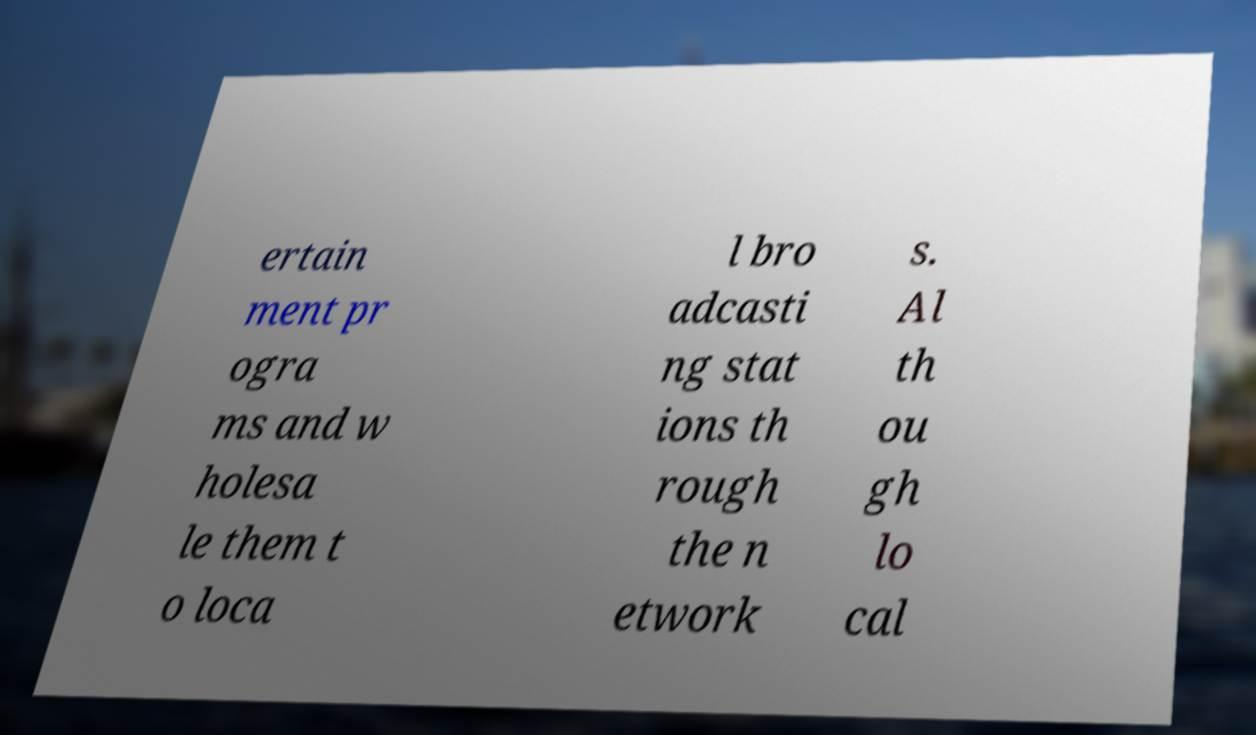For documentation purposes, I need the text within this image transcribed. Could you provide that? ertain ment pr ogra ms and w holesa le them t o loca l bro adcasti ng stat ions th rough the n etwork s. Al th ou gh lo cal 